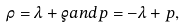Convert formula to latex. <formula><loc_0><loc_0><loc_500><loc_500>\rho = \lambda + \varrho a n d p = - \lambda + p ,</formula> 